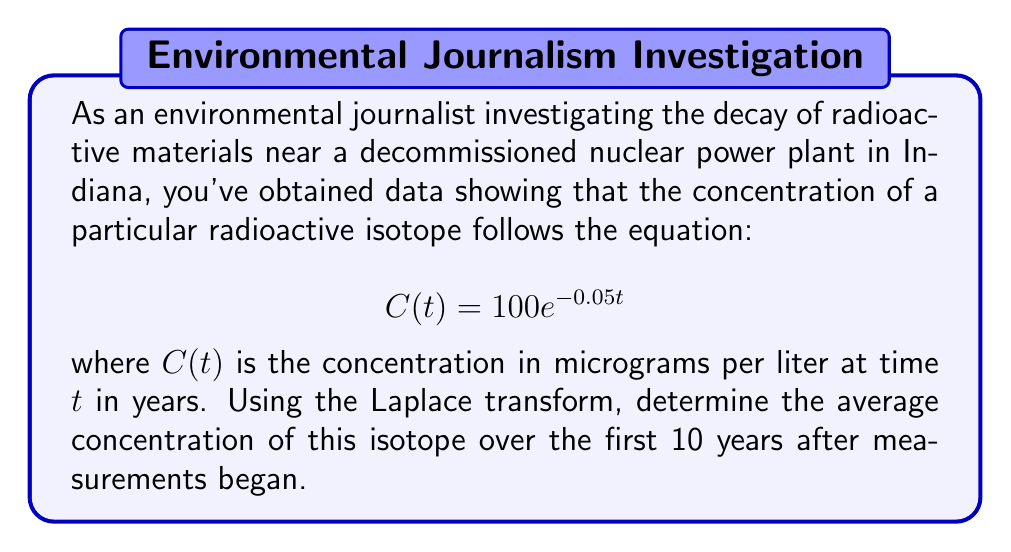Can you answer this question? To solve this problem using the Laplace transform, we'll follow these steps:

1) First, recall that the average value of a function $f(t)$ over an interval $[0,T]$ is given by:

   $$\text{Average} = \frac{1}{T}\int_0^T f(t) dt$$

2) In our case, $f(t) = C(t) = 100e^{-0.05t}$ and $T = 10$ years.

3) To use the Laplace transform, let's consider the function:

   $$F(s) = \mathcal{L}\{C(t)\} = \int_0^\infty 100e^{-0.05t}e^{-st}dt = \frac{100}{s+0.05}$$

4) Now, we can use the property of the Laplace transform that states:

   $$\int_0^T f(t)dt = \frac{1}{s}\left[F(s) - F(s)e^{-sT}\right]$$

5) Applying this to our problem:

   $$\int_0^{10} 100e^{-0.05t}dt = \frac{1}{s}\left[\frac{100}{s+0.05} - \frac{100}{s+0.05}e^{-10s}\right]$$

6) To evaluate this at $s=0$ (which gives us the integral we need), we use L'Hôpital's rule:

   $$\lim_{s\to 0} \frac{1}{s}\left[\frac{100}{s+0.05} - \frac{100}{s+0.05}e^{-10s}\right] = \lim_{s\to 0} \frac{100}{(s+0.05)^2}(1-e^{-10s}+10se^{-10s})$$

7) Evaluating this limit:

   $$\int_0^{10} 100e^{-0.05t}dt = \frac{100}{0.05^2}(1-e^{-0.5}) \approx 1810.04$$

8) Finally, to get the average, we divide by $T=10$:

   $$\text{Average} = \frac{1810.04}{10} = 181.004$$

Therefore, the average concentration over the first 10 years is approximately 181.004 micrograms per liter.
Answer: 181.004 micrograms per liter 